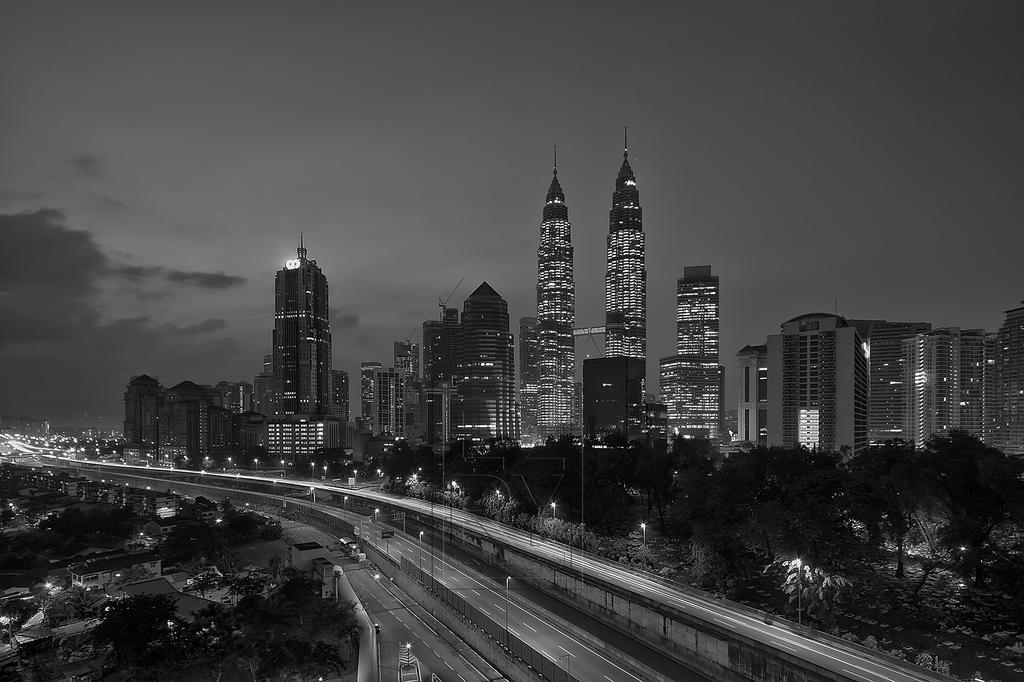What is located at the bottom of the image? There is a road and a bridge at the bottom of the image. What can be found along the road or bridge? There are poles visible in the image. What type of vegetation is on the right side of the image? There are trees on the right side of the image. What is visible in the background of the image? There are buildings and the sky visible in the background of the image. How many dogs are carrying a parcel across the bridge in the image? There are no dogs or parcels present in the image. What type of town is depicted in the image? The image does not depict a town; it features a road, bridge, poles, trees, buildings, and the sky. 